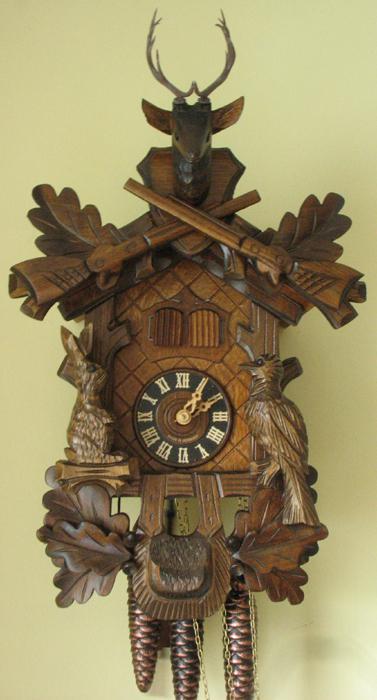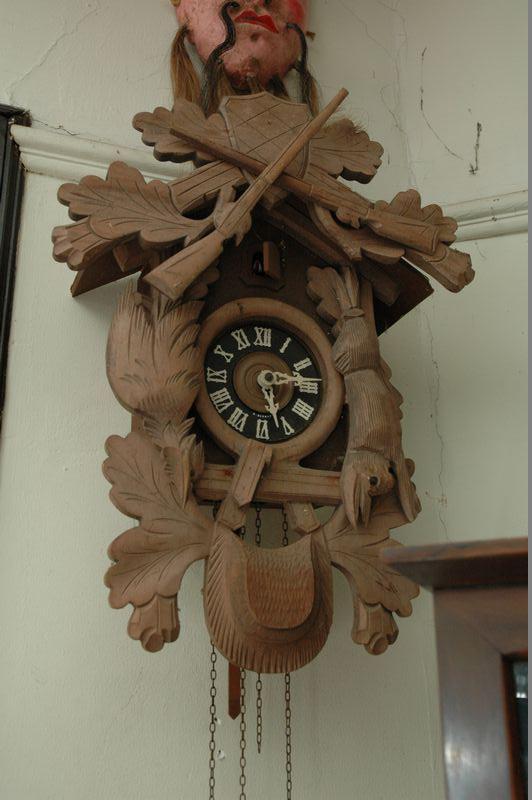The first image is the image on the left, the second image is the image on the right. For the images shown, is this caption "At least one object is made of wood." true? Answer yes or no. Yes. The first image is the image on the left, the second image is the image on the right. Considering the images on both sides, is "An image includes charms shaped like a rabbit, an acorn and a pinecone, displayed on a surface decorated with a foliage pattern." valid? Answer yes or no. No. 